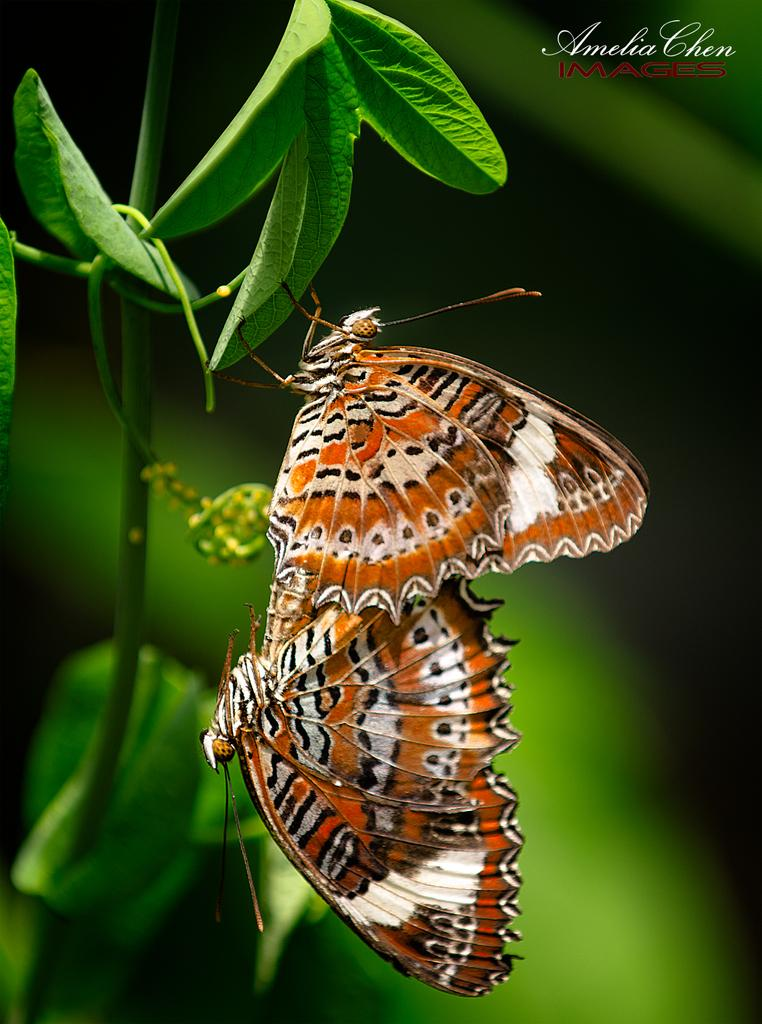What is present on the leaf in the image? There are butterflies on a leaf in the image. What can be found in the top right corner of the image? There is text in the top right corner of the image. Where is the text located? The text is on a tree. How many bears are visible in the image? There are no bears present in the image. What is the current temperature in the image? The image does not provide information about the current temperature. 